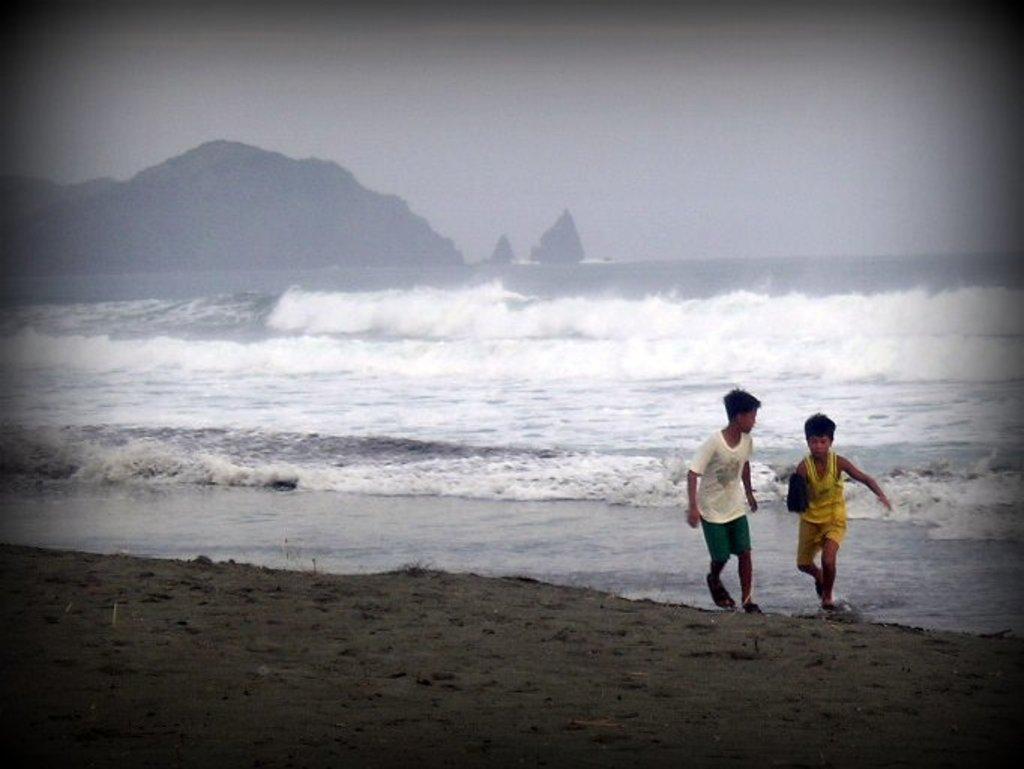Please provide a concise description of this image. In this picture we can see two boys running on sand and in the background we can see water, mountains, sky. 